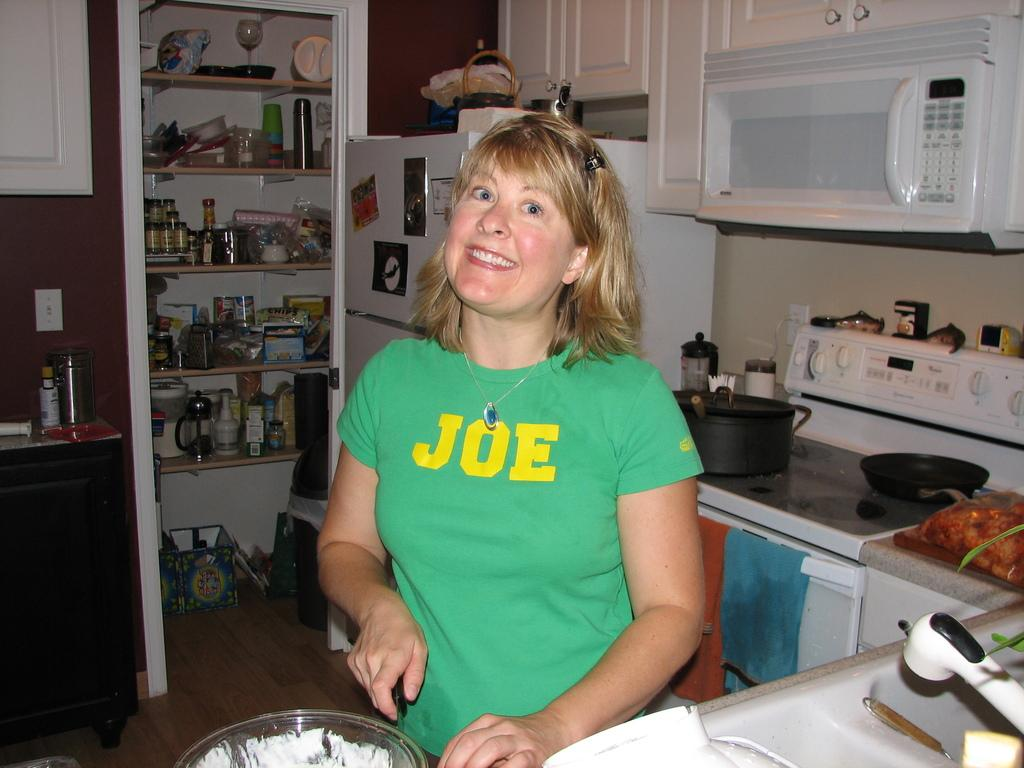<image>
Offer a succinct explanation of the picture presented. The lady pictured must really like a person called Joe. 